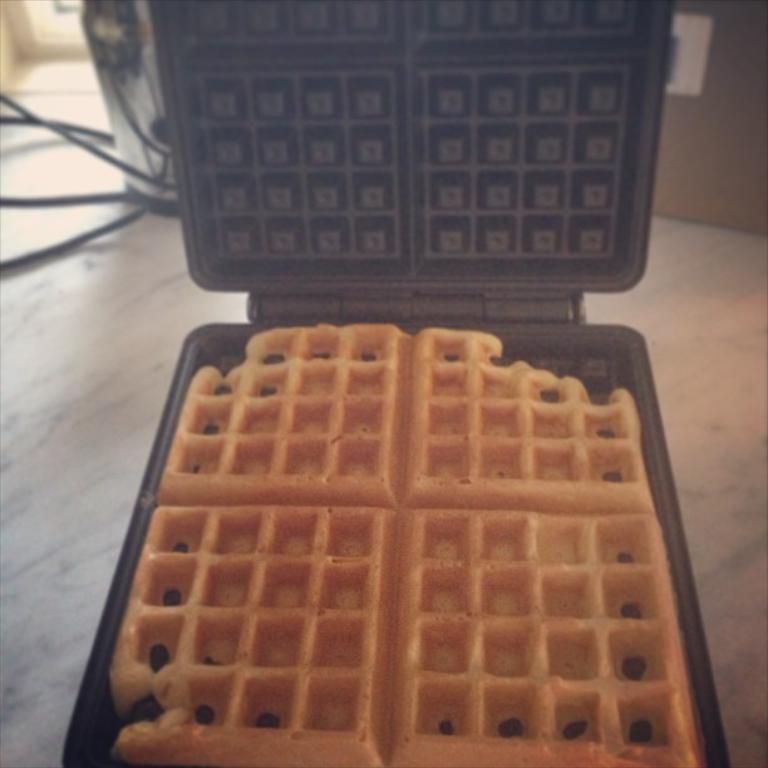Can you describe this image briefly? In the middle of the image we can see a waffle and a machine. 